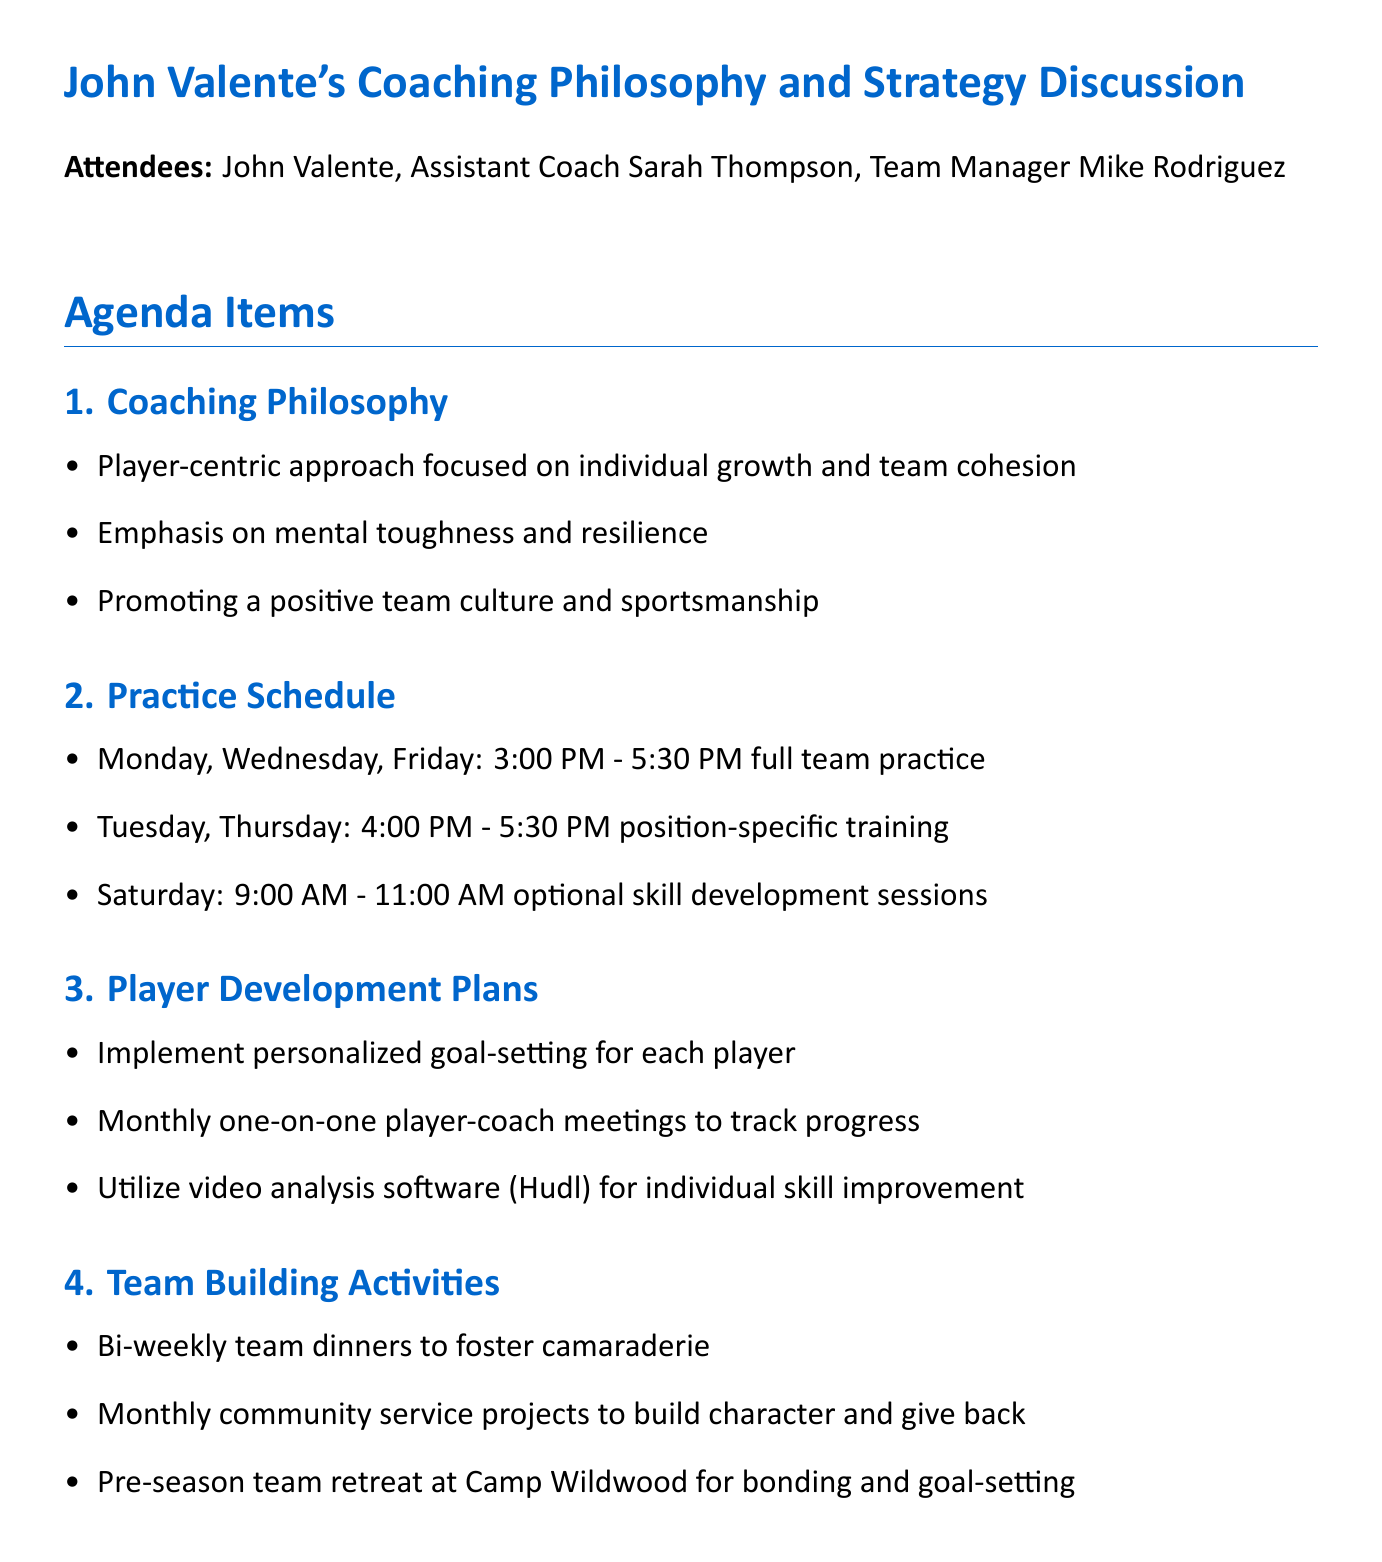What is the meeting date? The meeting date is explicitly stated at the beginning of the document.
Answer: May 15, 2023 Who attended the meeting? The attendees are listed in the document under the attendees section.
Answer: John Valente, Assistant Coach Sarah Thompson, Team Manager Mike Rodriguez How often are team dinners planned? The frequency of team dinners is mentioned in the team building activities section.
Answer: Bi-weekly What is the time for full team practice on Mondays? The schedule for full team practice is clearly outlined in the practice schedule section.
Answer: 3:00 PM - 5:30 PM What software will be used for video analysis? The document specifies the software to be used in the player development plans.
Answer: Hudl How will player progress be tracked? The method for tracking player progress is mentioned in the player development plans section.
Answer: Monthly one-on-one player-coach meetings When is the next meeting scheduled? The timing for the next meeting is provided in the last section of the document.
Answer: June 1, 2023 What type of activities are planned in the community service projects? The nature of activities is detailed in the team building activities section.
Answer: Monthly community service projects Who is responsible for booking Camp Wildwood? The action items specify tasks assigned to individuals during the meeting.
Answer: Mike 